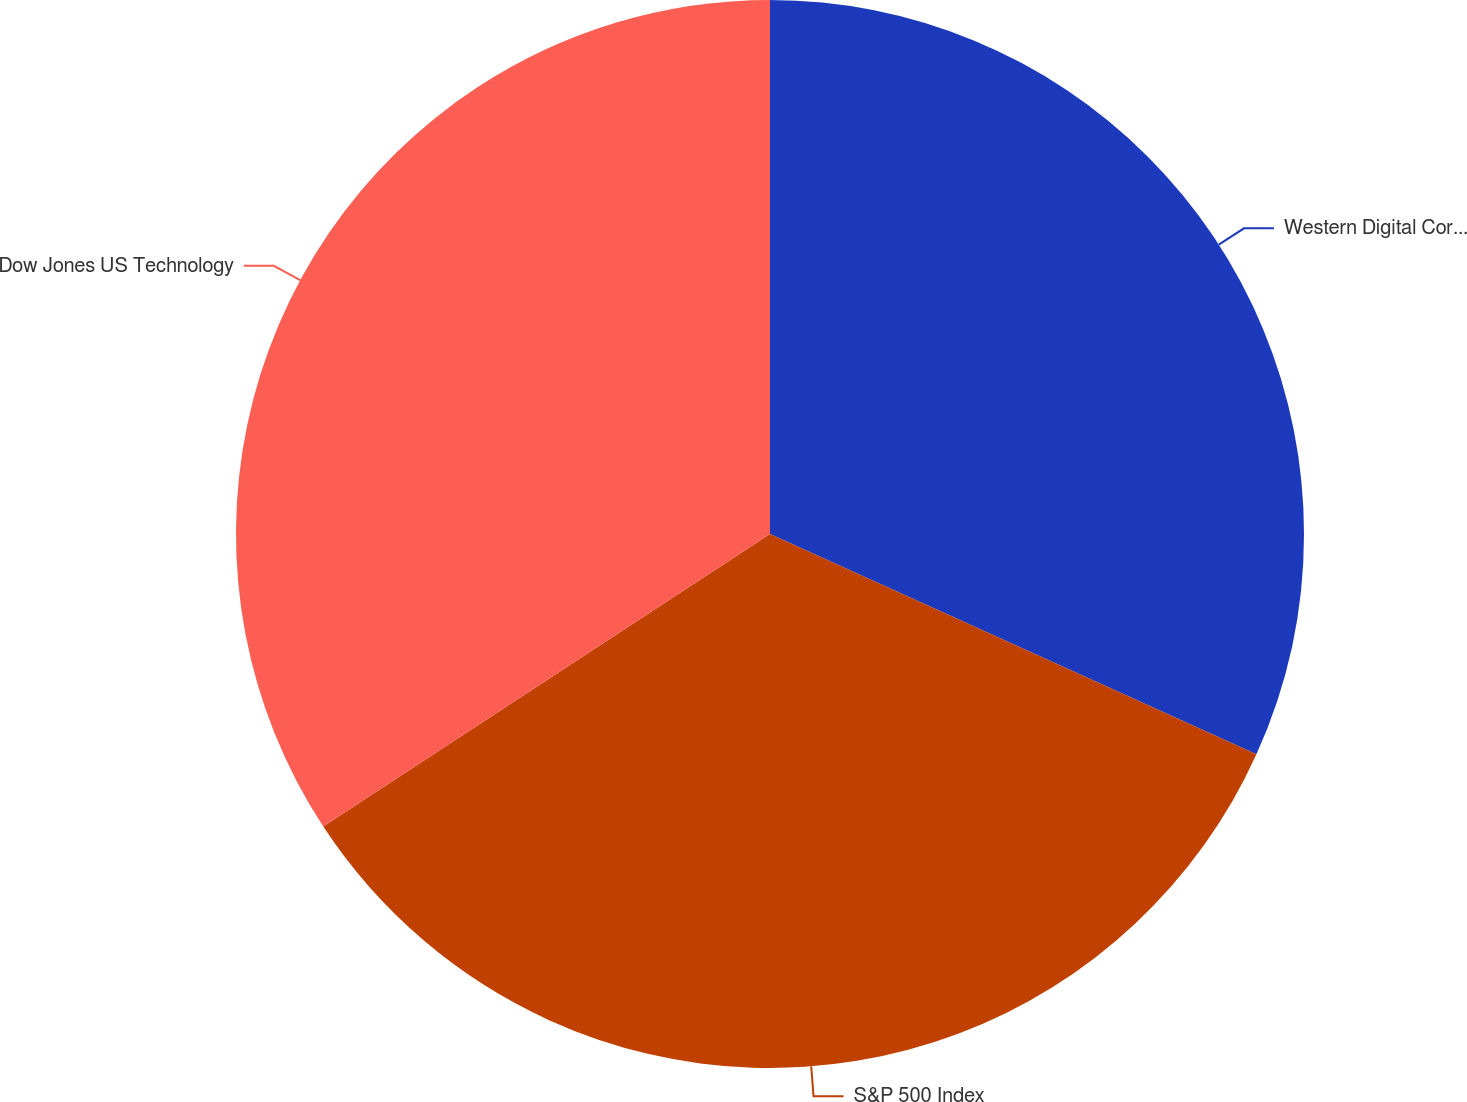<chart> <loc_0><loc_0><loc_500><loc_500><pie_chart><fcel>Western Digital Corporation<fcel>S&P 500 Index<fcel>Dow Jones US Technology<nl><fcel>31.77%<fcel>34.0%<fcel>34.23%<nl></chart> 